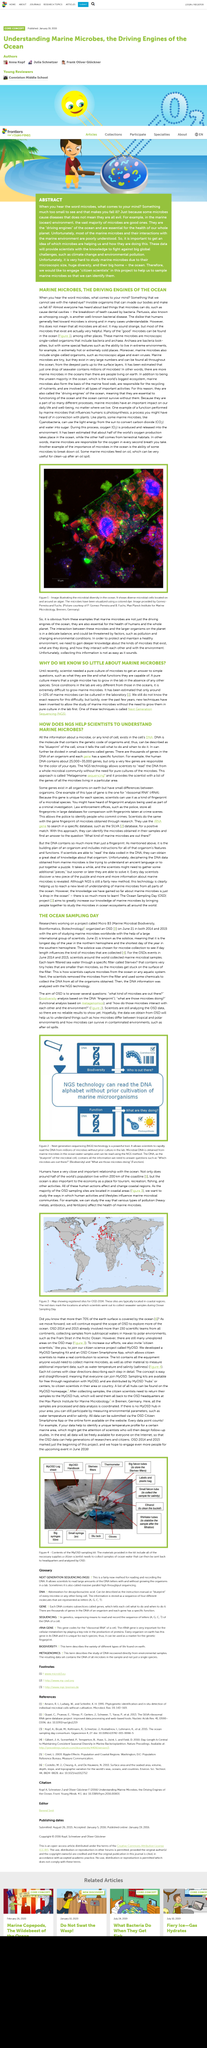List a handful of essential elements in this visual. Microbes are cultured in labs to determine their characteristics and capabilities. Yes, both humans and microbes share a common genetic code called DNA. The use of Next-Generation Sequencing (NGS) has several advantages, including the ability to analyze microbial communities without requiring the growth of microbes in pure culture. Next Generation Sequencing is a new technique that is being used to study genetic variations in individuals and populations. Metagenome sequencing results in the detection of DNA from both human and microbial sources. The analysis provides a comprehensive view of the entire microbial community within a given sample, including the genetic material of both host and non-host organisms. 